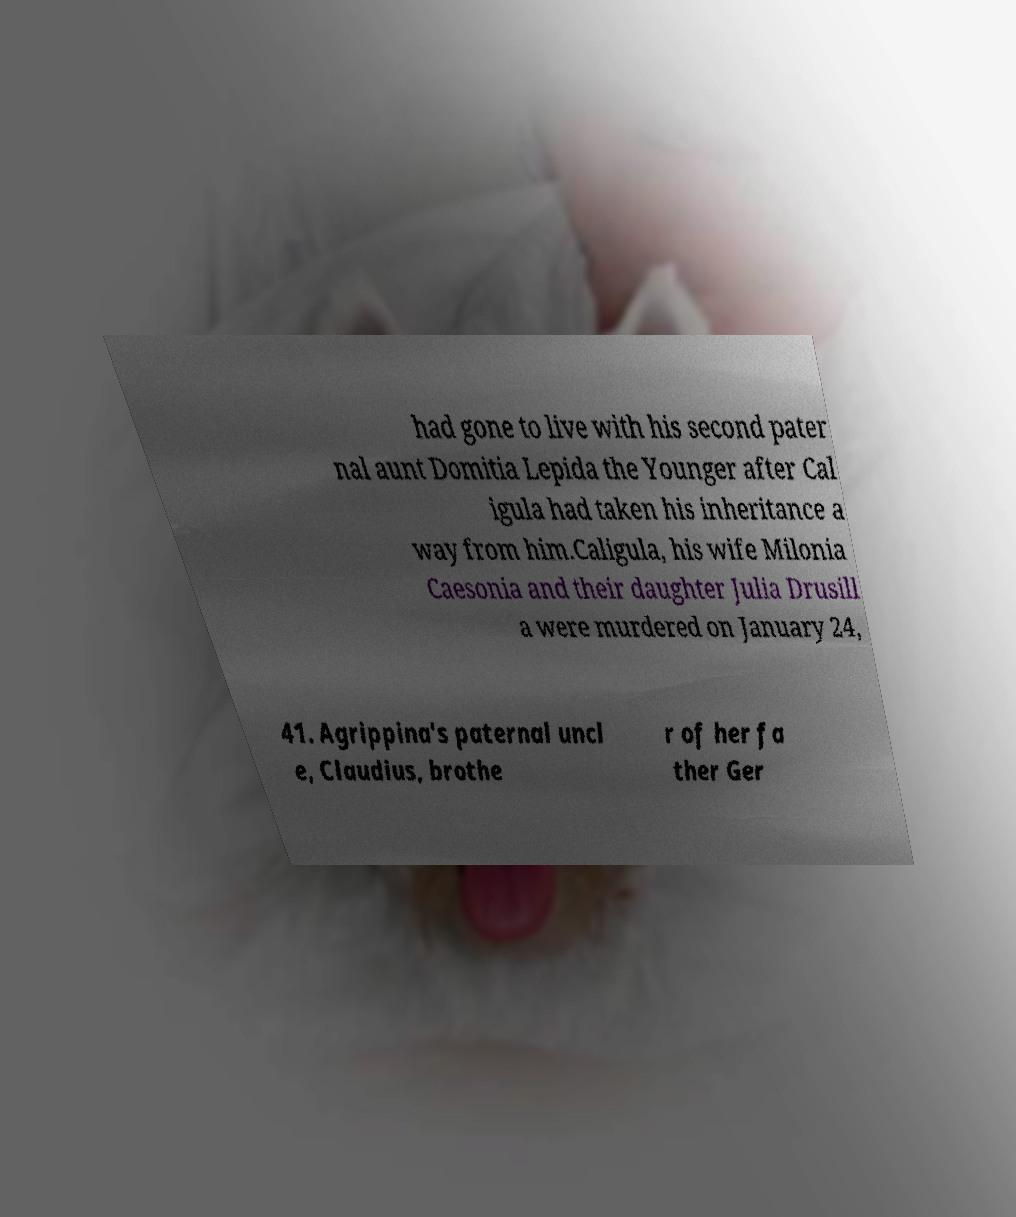For documentation purposes, I need the text within this image transcribed. Could you provide that? had gone to live with his second pater nal aunt Domitia Lepida the Younger after Cal igula had taken his inheritance a way from him.Caligula, his wife Milonia Caesonia and their daughter Julia Drusill a were murdered on January 24, 41. Agrippina's paternal uncl e, Claudius, brothe r of her fa ther Ger 